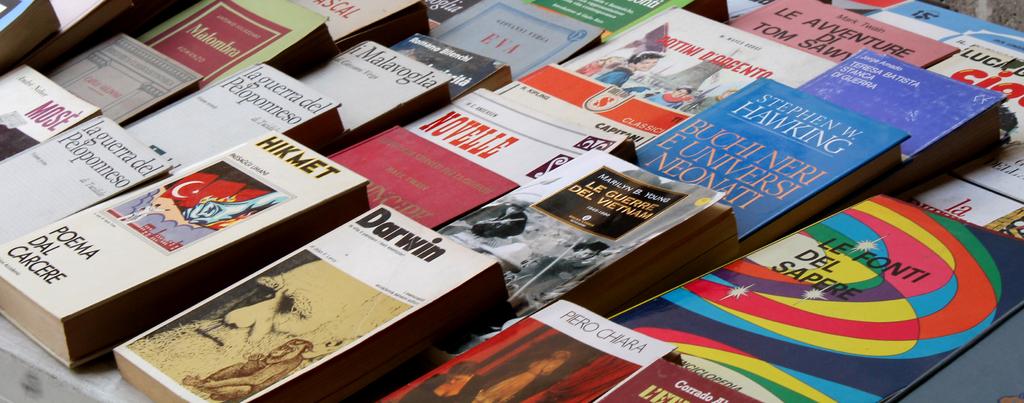What is written in red text in the middle of the image?
Give a very brief answer. Novelle. 